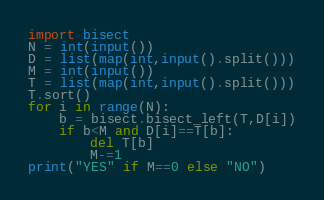Convert code to text. <code><loc_0><loc_0><loc_500><loc_500><_Python_>import bisect
N = int(input())
D = list(map(int,input().split()))
M = int(input())
T = list(map(int,input().split()))
T.sort()
for i in range(N):
    b = bisect.bisect_left(T,D[i])
    if b<M and D[i]==T[b]:
        del T[b]
        M-=1
print("YES" if M==0 else "NO")</code> 